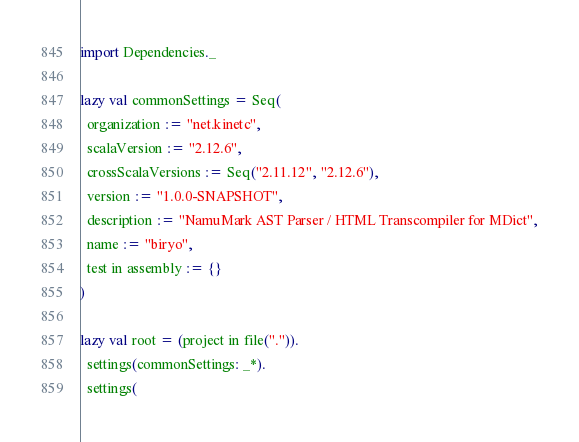<code> <loc_0><loc_0><loc_500><loc_500><_Scala_>import Dependencies._

lazy val commonSettings = Seq(
  organization := "net.kinetc",
  scalaVersion := "2.12.6",
  crossScalaVersions := Seq("2.11.12", "2.12.6"),
  version := "1.0.0-SNAPSHOT",
  description := "NamuMark AST Parser / HTML Transcompiler for MDict",
  name := "biryo",
  test in assembly := {}
)

lazy val root = (project in file(".")).
  settings(commonSettings: _*).
  settings(</code> 